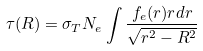<formula> <loc_0><loc_0><loc_500><loc_500>\tau ( R ) = \sigma _ { T } N _ { e } \int \frac { f _ { e } ( r ) r d r } { \sqrt { r ^ { 2 } - R ^ { 2 } } }</formula> 